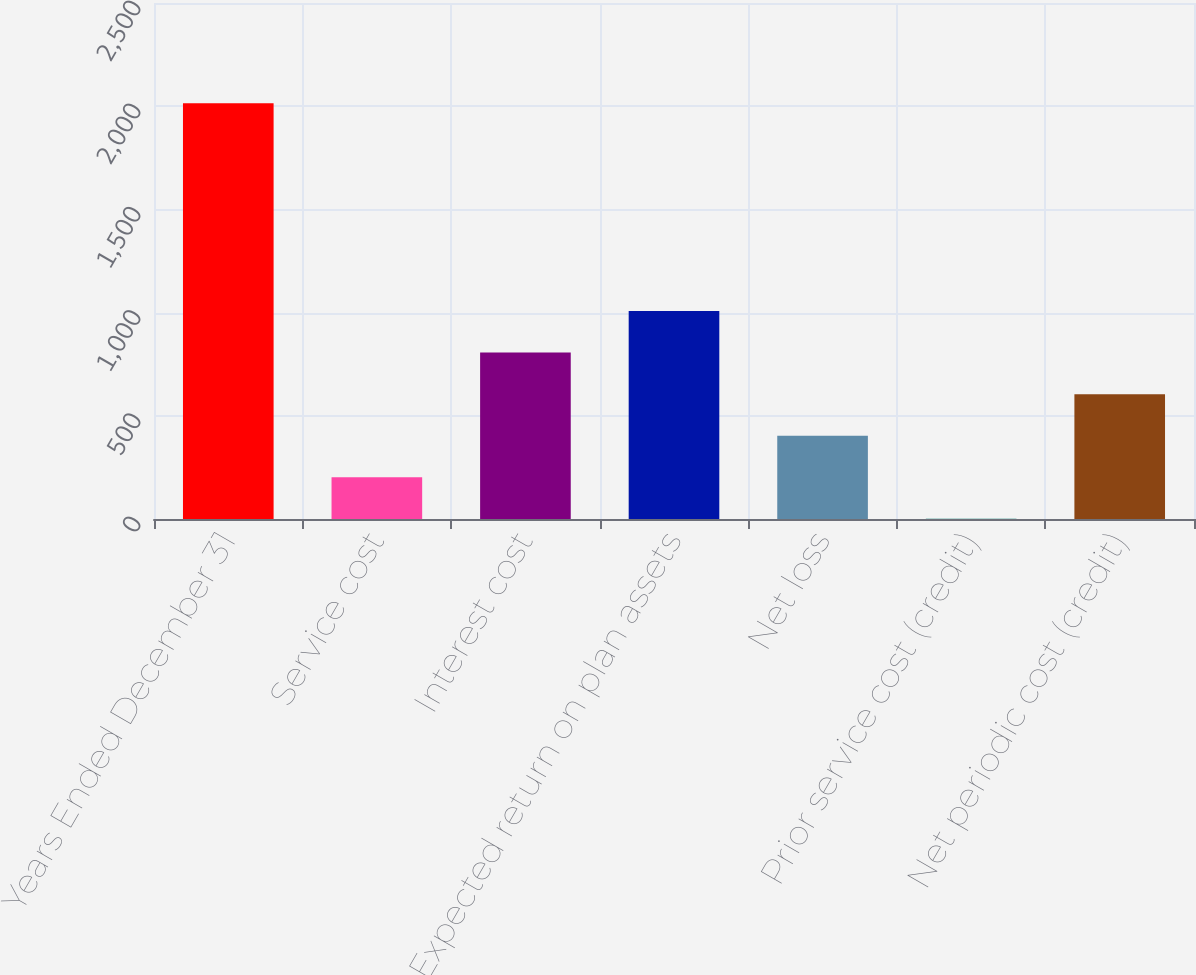Convert chart. <chart><loc_0><loc_0><loc_500><loc_500><bar_chart><fcel>Years Ended December 31<fcel>Service cost<fcel>Interest cost<fcel>Expected return on plan assets<fcel>Net loss<fcel>Prior service cost (credit)<fcel>Net periodic cost (credit)<nl><fcel>2014<fcel>202.3<fcel>806.2<fcel>1007.5<fcel>403.6<fcel>1<fcel>604.9<nl></chart> 